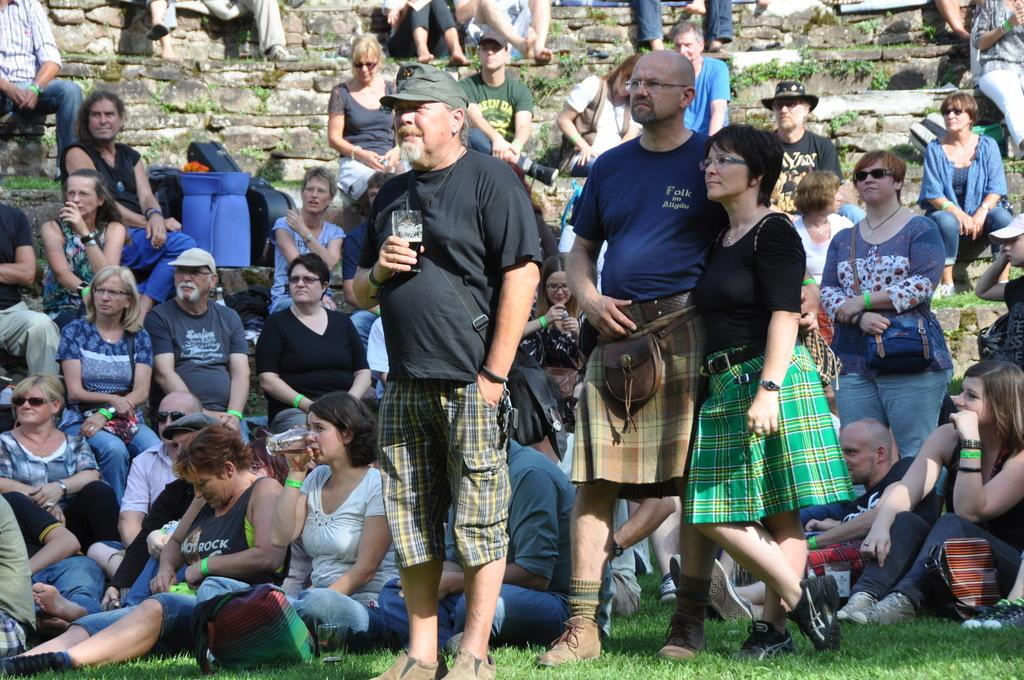How many people are in the image? There is a group of people in the image. What are some of the people doing in the image? Some of the people are standing, and some are sitting. What can be seen in the background of the image? There is a wall and plants in the background of the image. What type of ground is visible at the bottom of the image? There is grass at the bottom of the image. What type of sock is hanging from the curtain in the image? There is no sock or curtain present in the image. 